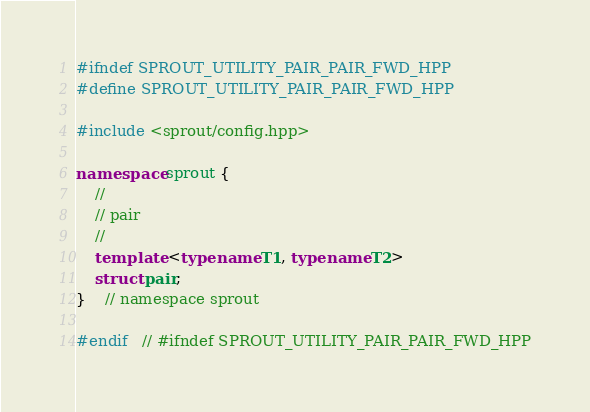<code> <loc_0><loc_0><loc_500><loc_500><_C++_>#ifndef SPROUT_UTILITY_PAIR_PAIR_FWD_HPP
#define SPROUT_UTILITY_PAIR_PAIR_FWD_HPP

#include <sprout/config.hpp>

namespace sprout {
	//
	// pair
	//
	template <typename T1, typename T2>
	struct pair;
}	// namespace sprout

#endif	// #ifndef SPROUT_UTILITY_PAIR_PAIR_FWD_HPP
</code> 